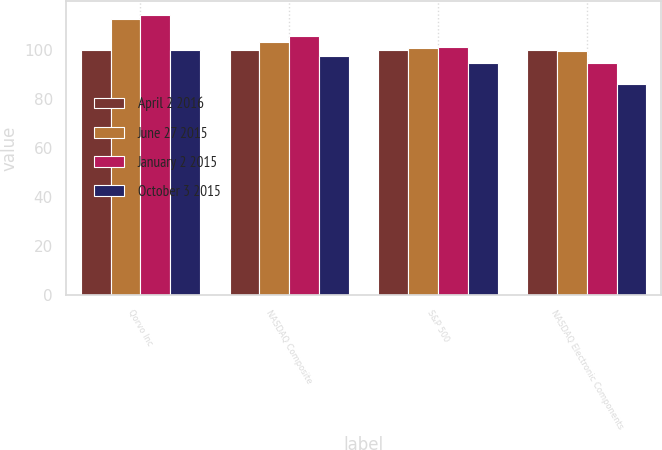<chart> <loc_0><loc_0><loc_500><loc_500><stacked_bar_chart><ecel><fcel>Qorvo Inc<fcel>NASDAQ Composite<fcel>S&P 500<fcel>NASDAQ Electronic Components<nl><fcel>April 2 2016<fcel>100<fcel>100<fcel>100<fcel>100<nl><fcel>June 27 2015<fcel>112.61<fcel>103.33<fcel>100.95<fcel>99.37<nl><fcel>January 2 2015<fcel>114.22<fcel>105.49<fcel>101.23<fcel>94.72<nl><fcel>October 3 2015<fcel>100<fcel>97.6<fcel>94.71<fcel>86.12<nl></chart> 